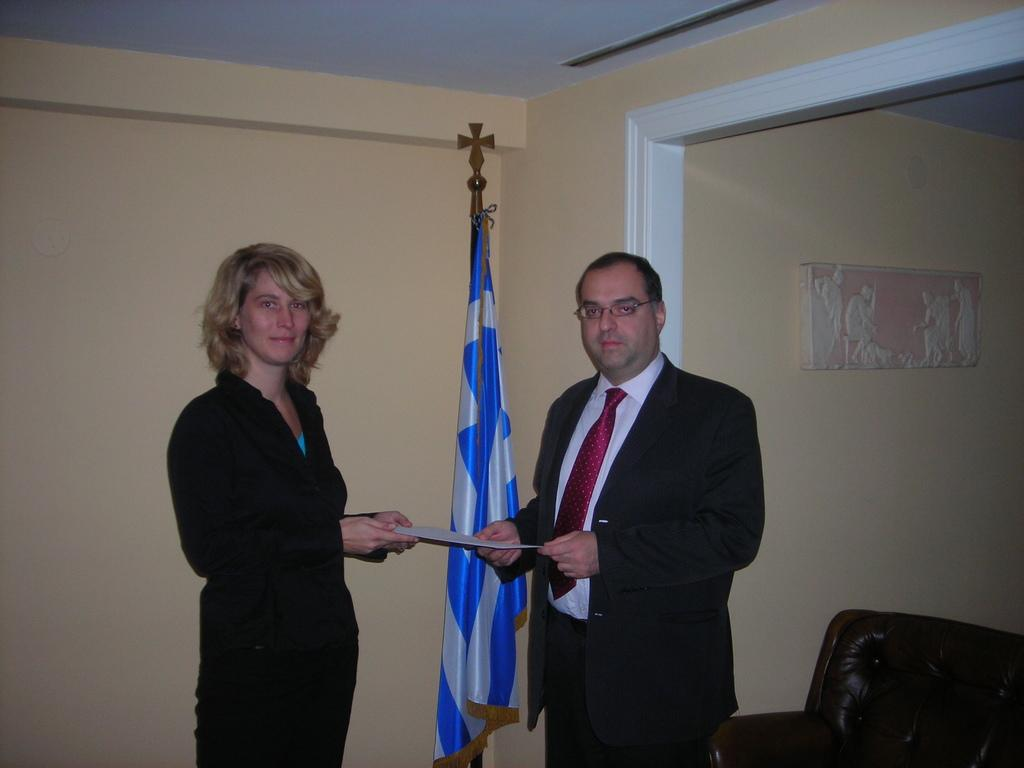What is happening between the man and the woman in the image? A man is giving a certificate to a woman. What can be seen behind the man and the woman? There is a wall behind them. Is there any symbol or emblem visible in the image? Yes, there is a flag visible. Can you tell me how many snakes are slithering on the floor in the image? There are no snakes present in the image. What type of rod can be seen being used by the man in the image? There is no rod being used by the man in the image. 